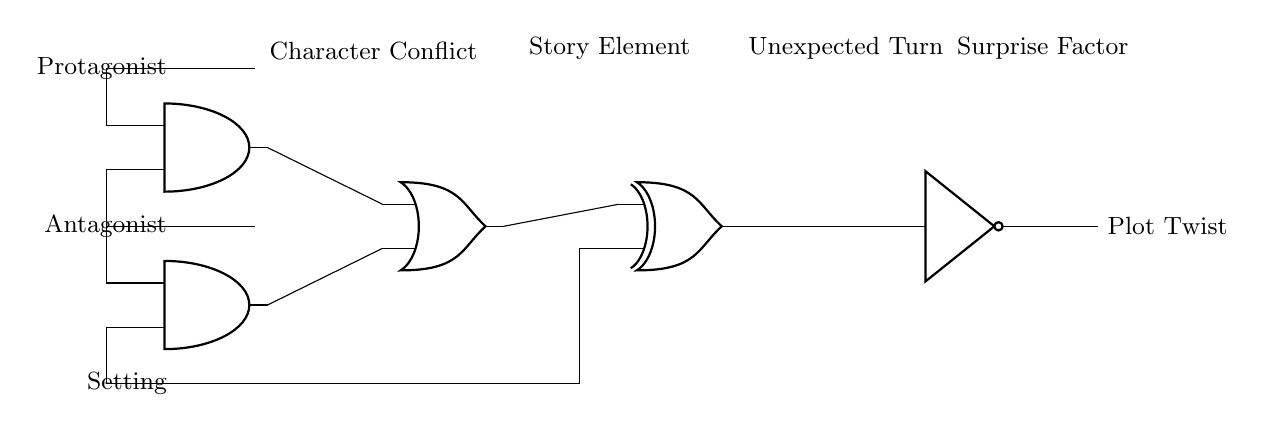What are the input signals in this circuit? The input signals are the protagonist, antagonist, and setting, which are connected to the AND gates.
Answer: Protagonist, Antagonist, Setting What type of gate produces the plot twist output? The final output is generated by the NOT gate, which inverts the output from the XOR gate preceding it.
Answer: NOT gate How many AND gates are in the circuit? There are two AND gates present in the circuit diagram, involved in processing the input signals.
Answer: 2 Which component connects the outputs of the AND gates? The outputs of the AND gates are connected to an OR gate, which combines their outputs before sending them to the XOR gate.
Answer: OR gate What role does the XOR gate play in this circuit? The XOR gate takes two inputs: the output from the OR gate and the setting, to introduce complexity in the plot twist generation.
Answer: Complexity What is the relationship between the antagonist and the setting as per this circuit? The antagonist and the setting are both input signals going into one of the AND gates, suggesting a potential conflict involving both in the story.
Answer: Conflict How does the output “Plot Twist” change if one input in the AND gates is altered? Changing one input alters the logic of the gates, potentially producing a different output at the NOT gate resulting in a different plot twist.
Answer: Different plot twist 